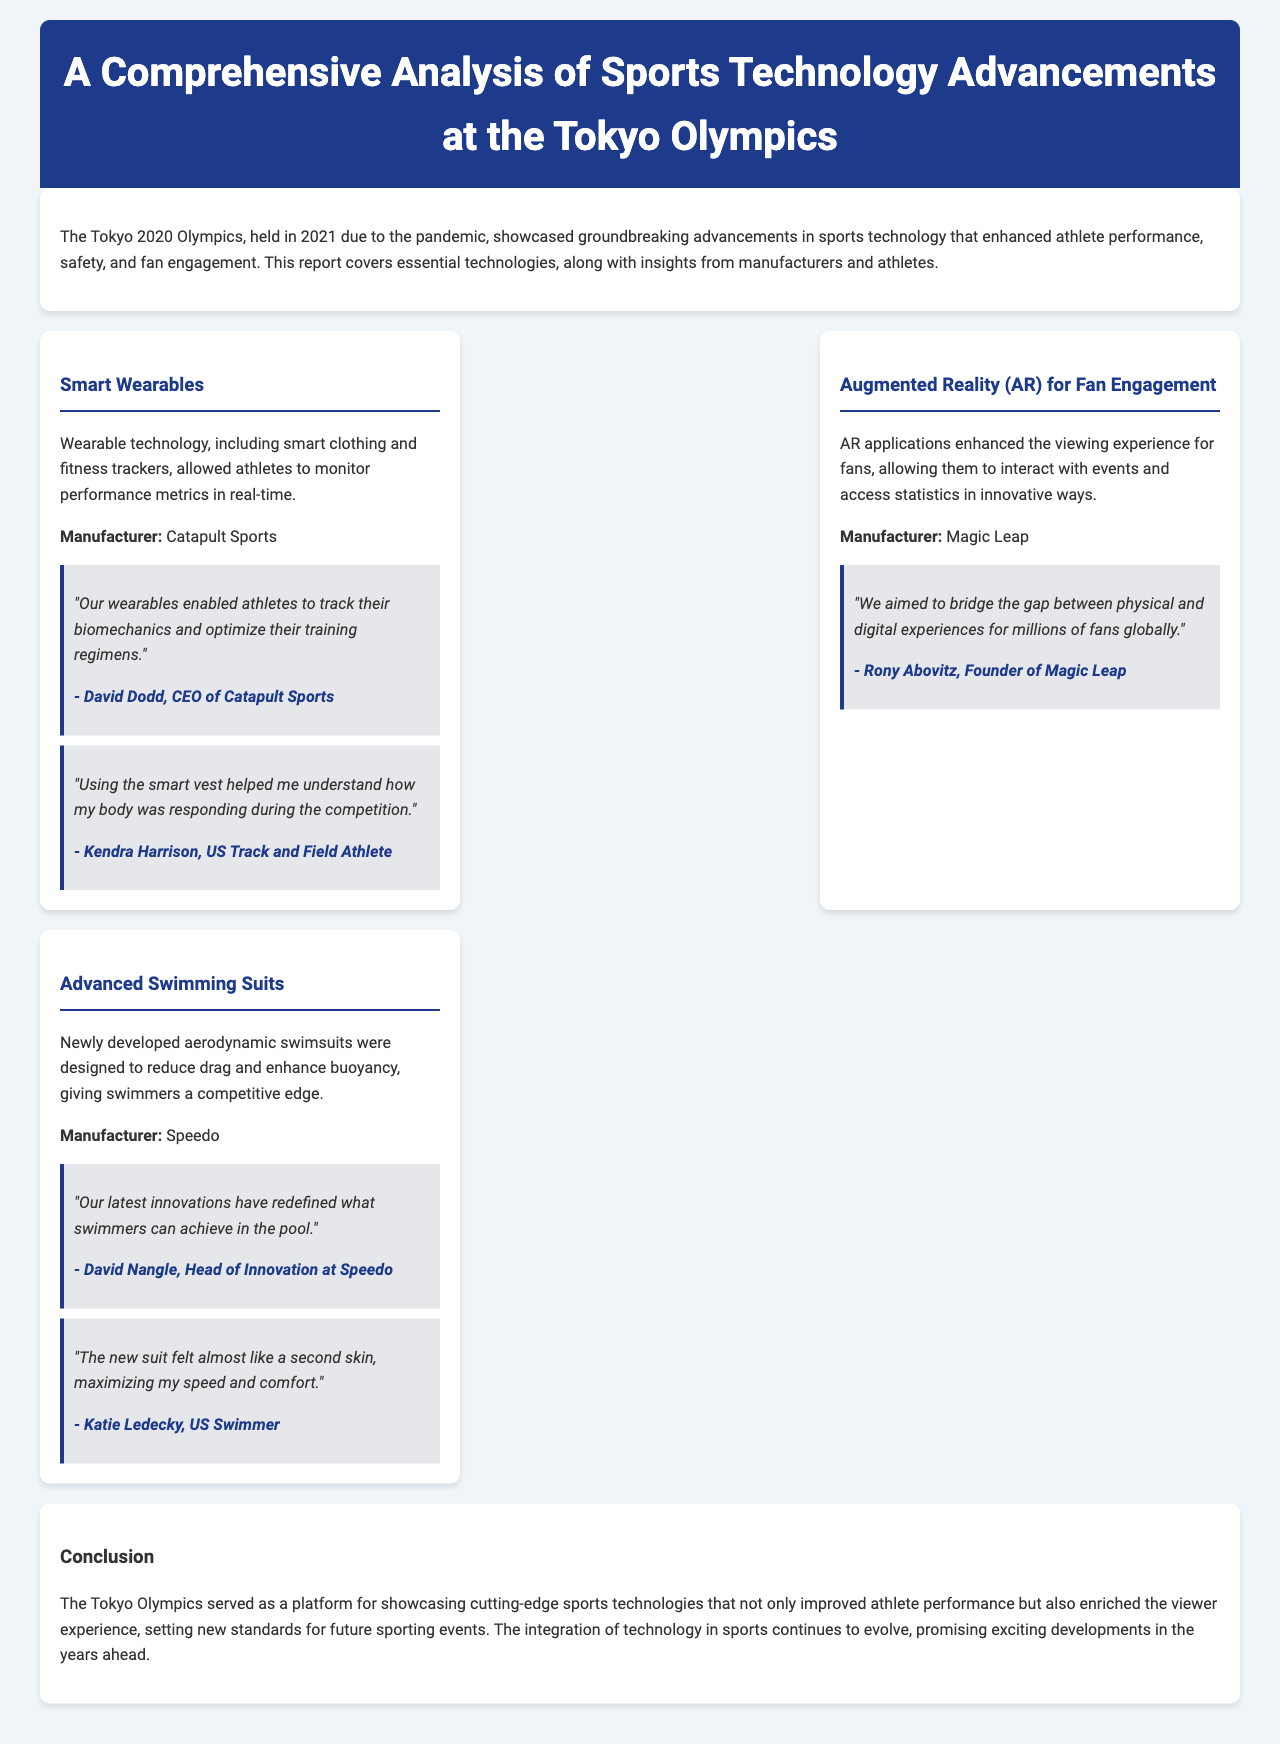What technology allowed athletes to monitor performance metrics in real-time? The document mentions that wearable technology, including smart clothing and fitness trackers, allowed athletes to monitor performance metrics in real-time.
Answer: Smart Wearables Who is the CEO of Catapult Sports? The document provides information that David Dodd is the CEO of Catapult Sports.
Answer: David Dodd What is the main purpose of the AR applications mentioned? The AR applications aimed to enhance the viewing experience for fans by allowing them to interact with events and access statistics.
Answer: Fan Engagement Which company developed the advanced swimming suits? The document states that Speedo is the manufacturer of the advanced swimming suits.
Answer: Speedo What feedback did Katie Ledecky provide about the new swimming suit? Katie Ledecky mentioned that the new suit felt almost like a second skin, maximizing speed and comfort.
Answer: Second skin How did Rony Abovitz describe the goal of Magic Leap's technology? Rony Abovitz said they aimed to bridge the gap between physical and digital experiences for fans.
Answer: Bridge the gap What was a major outcome of showcasing technology at the Tokyo Olympics? The report concludes that the technology showcased at the Tokyo Olympics improved athlete performance and enriched viewer experience.
Answer: Improved athlete performance Which year were the Tokyo Olympics originally scheduled before the delay? The document states that the Tokyo Olympics were originally scheduled for the year 2020 before being held in 2021.
Answer: 2020 